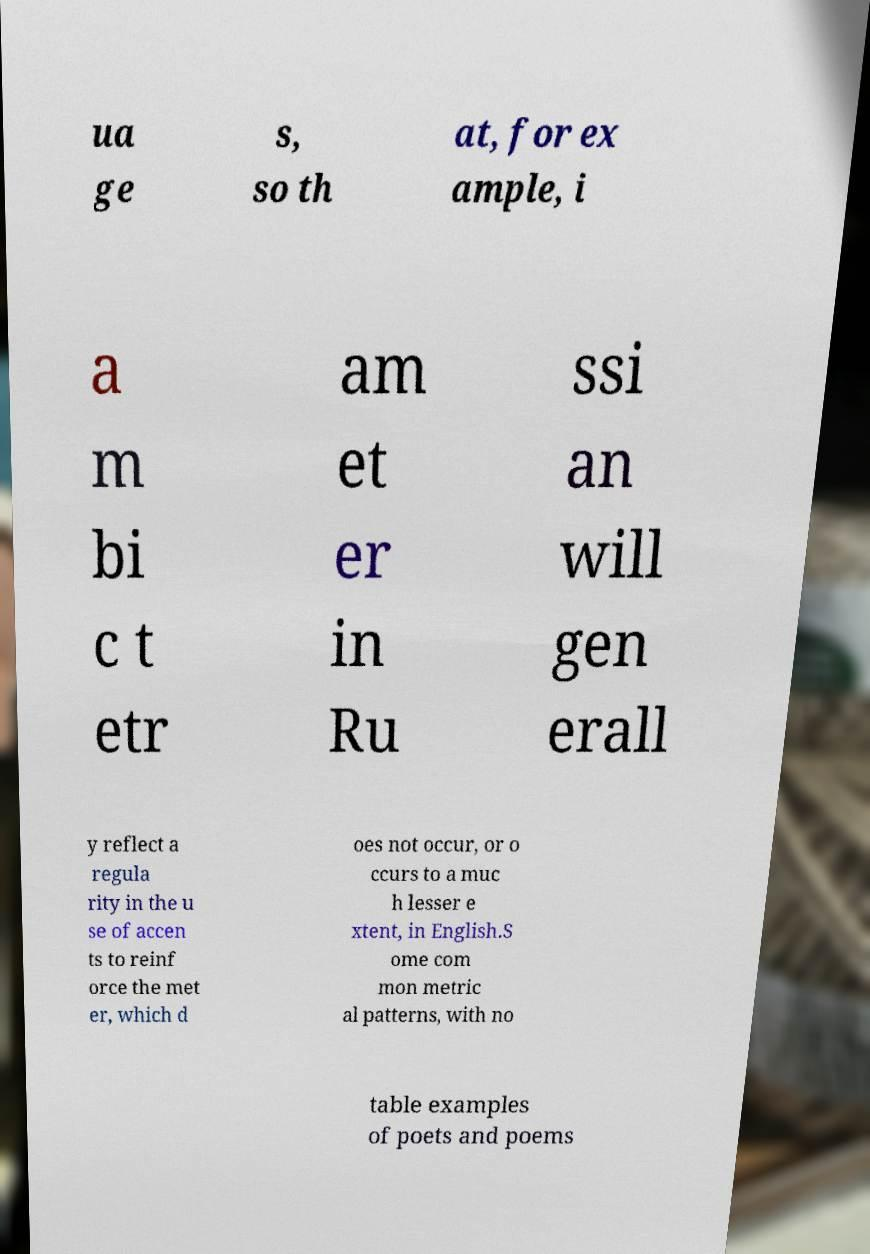What messages or text are displayed in this image? I need them in a readable, typed format. ua ge s, so th at, for ex ample, i a m bi c t etr am et er in Ru ssi an will gen erall y reflect a regula rity in the u se of accen ts to reinf orce the met er, which d oes not occur, or o ccurs to a muc h lesser e xtent, in English.S ome com mon metric al patterns, with no table examples of poets and poems 